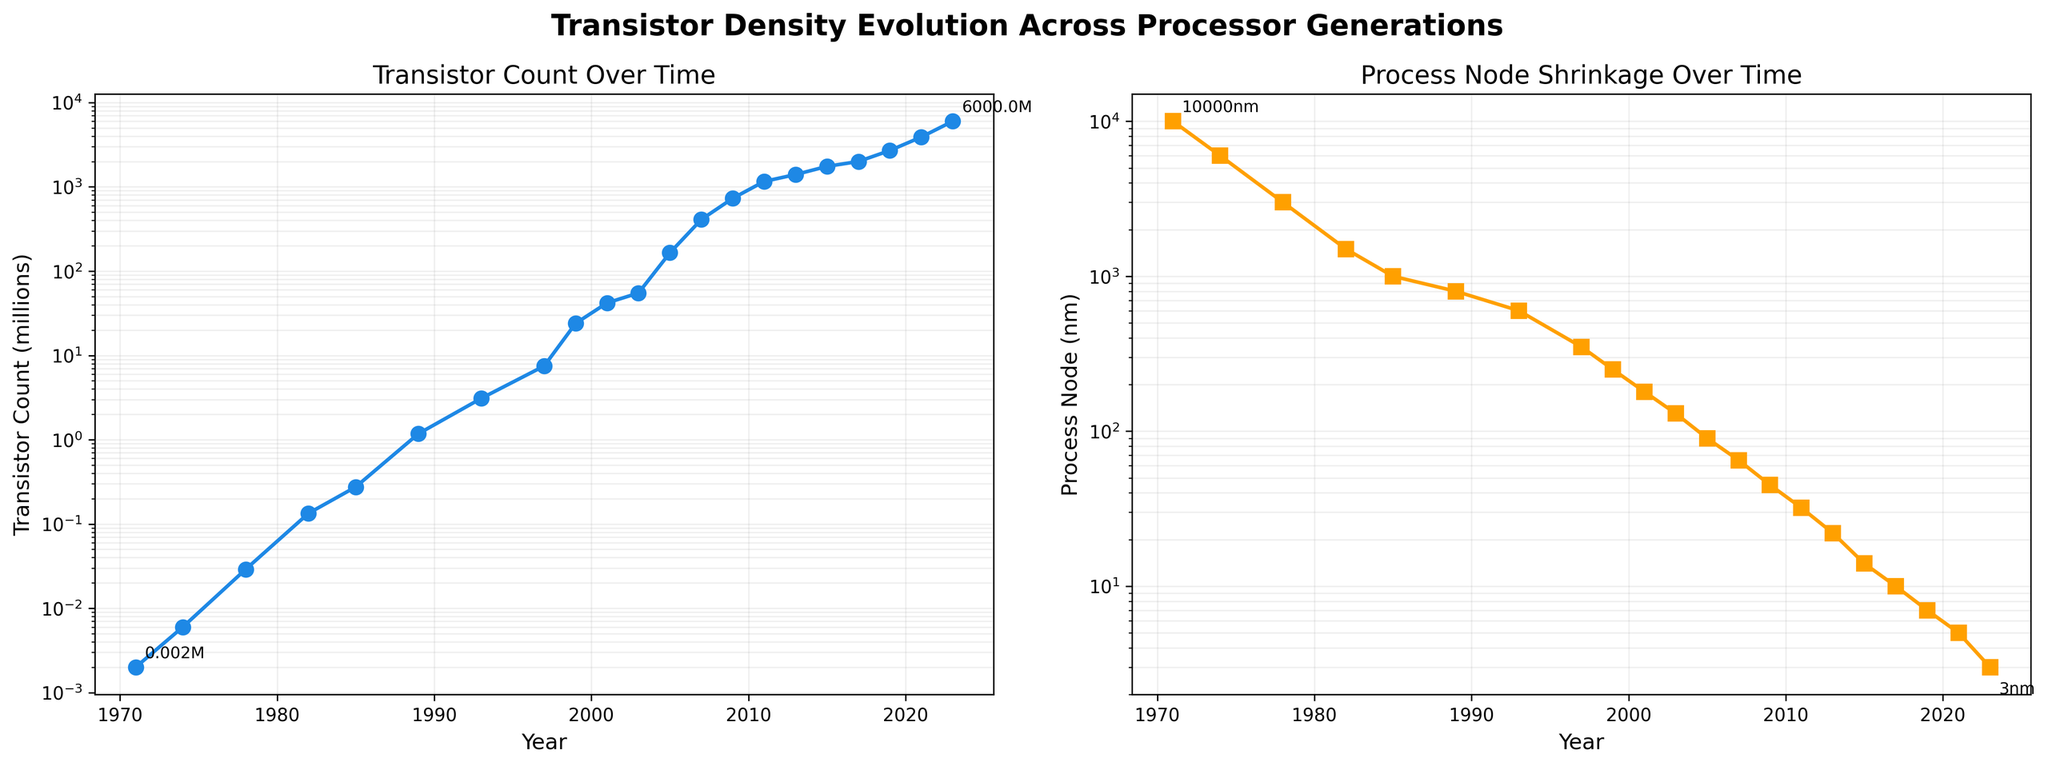What is the trend of transistor count over the years? We can see that the transistor count has been increasing exponentially over the years. This trend is evident from the upward curve in the first plot showing Transistor Count Over Time.
Answer: Increasing exponentially How much did the transistor count increase between 1971 and 2023? The transistor count in 1971 was 0.002 million and in 2023 it was 6000 million. The increase is calculated by subtracting the 1971 value from the 2023 value, which gives 6000 - 0.002 = 5999.998 million.
Answer: 5999.998 million How has the process node size changed from 1971 to 2023? The process node size has reduced significantly from 10000 nm in 1971 to 3 nm in 2023. This is visible in the second plot showing Process Node Shrinkage Over Time.
Answer: Reduced significantly In what year did the transistor count first exceed 100 million? From inspecting the first plot, the transistor count exceeded 100 million between 2001 and 2003. In 2003, it reached 165 million.
Answer: 2003 Compare the rate of change in transistor count and process node size reductions between 1971 and 2023. Which one had a more pronounced change? Both the transistor count and process node size show exponential changes, but the process node size saw a more drastic reduction from 10000 nm to 3 nm. Transistor count went from 0.002 million to 6000 million. Visually, the steepness of the two curves indicates that process node shrinkage is more pronounced.
Answer: Process node size When did the process node size fall below 100 nm? The process node size fell below 100 nm between 2003 and 2005. In 2005, the process node size was 90 nm.
Answer: Between 2003 and 2005 Examine the visual attributes of lines in both plots. Which color represents the Transistor Count, and which represents the Process Node? The first plot, representing Transistor Count Over Time, uses a blue line, and the second plot, representing Process Node Shrinkage Over Time, uses an orange line.
Answer: Blue for Transistor Count, Orange for Process Node What year saw the largest drop in process node size according to the visual trend in the second plot? The largest drop in process node size occurred between 2017 and 2019, as seen by the steepest decline in the plot. The process node size went from 10 nm to 7 nm.
Answer: Between 2017 and 2019 Given the trend, what could you infer about the future changes in transistor count and process node size? Based on the exponential trends visible in both plots, we can infer that transistor counts will continue to increase, while process node sizes will continue to decrease, though both are approaching practical physical and technological limits.
Answer: Continued increase in transistor counts, decrease in process node size 